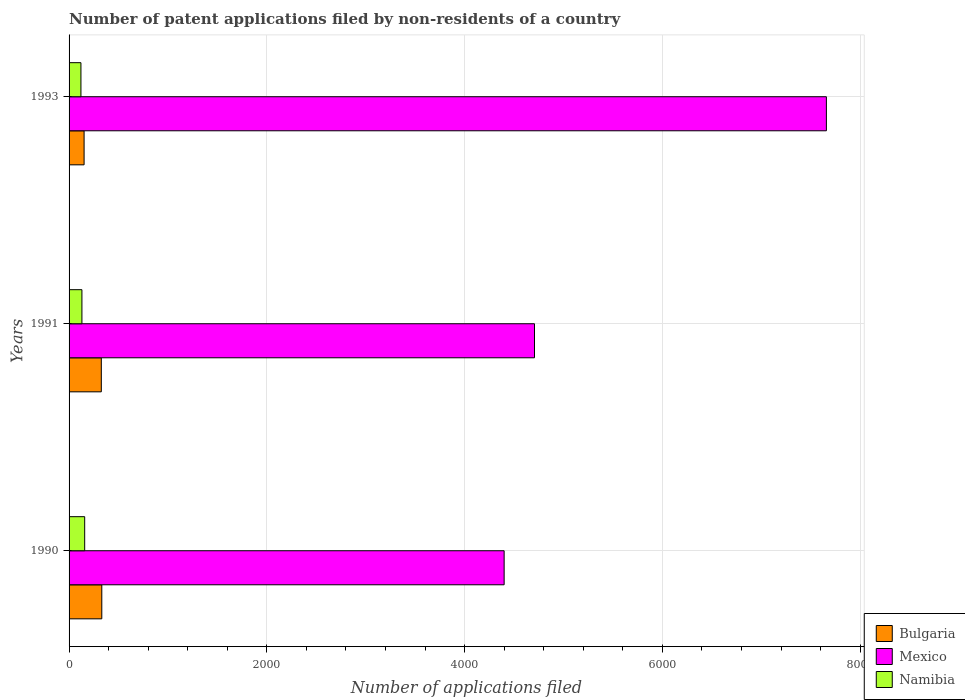How many different coloured bars are there?
Your response must be concise. 3. How many groups of bars are there?
Your answer should be very brief. 3. How many bars are there on the 1st tick from the top?
Make the answer very short. 3. What is the label of the 2nd group of bars from the top?
Your answer should be compact. 1991. What is the number of applications filed in Bulgaria in 1991?
Your answer should be compact. 326. Across all years, what is the maximum number of applications filed in Bulgaria?
Ensure brevity in your answer.  331. Across all years, what is the minimum number of applications filed in Mexico?
Offer a very short reply. 4400. What is the total number of applications filed in Mexico in the graph?
Ensure brevity in your answer.  1.68e+04. What is the difference between the number of applications filed in Bulgaria in 1991 and that in 1993?
Your answer should be compact. 174. What is the difference between the number of applications filed in Namibia in 1993 and the number of applications filed in Mexico in 1991?
Your answer should be compact. -4587. What is the average number of applications filed in Bulgaria per year?
Ensure brevity in your answer.  269.67. In the year 1990, what is the difference between the number of applications filed in Namibia and number of applications filed in Mexico?
Make the answer very short. -4242. In how many years, is the number of applications filed in Bulgaria greater than 4400 ?
Offer a terse response. 0. What is the ratio of the number of applications filed in Namibia in 1990 to that in 1991?
Provide a succinct answer. 1.22. Is the difference between the number of applications filed in Namibia in 1991 and 1993 greater than the difference between the number of applications filed in Mexico in 1991 and 1993?
Offer a terse response. Yes. What is the difference between the highest and the lowest number of applications filed in Bulgaria?
Your response must be concise. 179. Is the sum of the number of applications filed in Namibia in 1990 and 1993 greater than the maximum number of applications filed in Mexico across all years?
Provide a succinct answer. No. What does the 3rd bar from the bottom in 1990 represents?
Offer a very short reply. Namibia. Is it the case that in every year, the sum of the number of applications filed in Mexico and number of applications filed in Bulgaria is greater than the number of applications filed in Namibia?
Your answer should be compact. Yes. Are all the bars in the graph horizontal?
Provide a short and direct response. Yes. How many years are there in the graph?
Offer a terse response. 3. Are the values on the major ticks of X-axis written in scientific E-notation?
Give a very brief answer. No. Does the graph contain grids?
Give a very brief answer. Yes. How many legend labels are there?
Your response must be concise. 3. How are the legend labels stacked?
Your response must be concise. Vertical. What is the title of the graph?
Your response must be concise. Number of patent applications filed by non-residents of a country. What is the label or title of the X-axis?
Provide a short and direct response. Number of applications filed. What is the Number of applications filed in Bulgaria in 1990?
Your answer should be compact. 331. What is the Number of applications filed in Mexico in 1990?
Your answer should be compact. 4400. What is the Number of applications filed of Namibia in 1990?
Make the answer very short. 158. What is the Number of applications filed in Bulgaria in 1991?
Your response must be concise. 326. What is the Number of applications filed in Mexico in 1991?
Your answer should be compact. 4707. What is the Number of applications filed of Namibia in 1991?
Offer a terse response. 130. What is the Number of applications filed of Bulgaria in 1993?
Offer a very short reply. 152. What is the Number of applications filed of Mexico in 1993?
Provide a succinct answer. 7659. What is the Number of applications filed in Namibia in 1993?
Keep it short and to the point. 120. Across all years, what is the maximum Number of applications filed of Bulgaria?
Keep it short and to the point. 331. Across all years, what is the maximum Number of applications filed in Mexico?
Your response must be concise. 7659. Across all years, what is the maximum Number of applications filed in Namibia?
Your response must be concise. 158. Across all years, what is the minimum Number of applications filed in Bulgaria?
Give a very brief answer. 152. Across all years, what is the minimum Number of applications filed in Mexico?
Make the answer very short. 4400. Across all years, what is the minimum Number of applications filed of Namibia?
Your answer should be very brief. 120. What is the total Number of applications filed of Bulgaria in the graph?
Your response must be concise. 809. What is the total Number of applications filed in Mexico in the graph?
Give a very brief answer. 1.68e+04. What is the total Number of applications filed in Namibia in the graph?
Your answer should be compact. 408. What is the difference between the Number of applications filed in Bulgaria in 1990 and that in 1991?
Offer a very short reply. 5. What is the difference between the Number of applications filed in Mexico in 1990 and that in 1991?
Ensure brevity in your answer.  -307. What is the difference between the Number of applications filed of Namibia in 1990 and that in 1991?
Ensure brevity in your answer.  28. What is the difference between the Number of applications filed of Bulgaria in 1990 and that in 1993?
Provide a succinct answer. 179. What is the difference between the Number of applications filed in Mexico in 1990 and that in 1993?
Provide a short and direct response. -3259. What is the difference between the Number of applications filed of Namibia in 1990 and that in 1993?
Offer a very short reply. 38. What is the difference between the Number of applications filed of Bulgaria in 1991 and that in 1993?
Offer a terse response. 174. What is the difference between the Number of applications filed of Mexico in 1991 and that in 1993?
Provide a succinct answer. -2952. What is the difference between the Number of applications filed of Namibia in 1991 and that in 1993?
Offer a terse response. 10. What is the difference between the Number of applications filed in Bulgaria in 1990 and the Number of applications filed in Mexico in 1991?
Your answer should be compact. -4376. What is the difference between the Number of applications filed in Bulgaria in 1990 and the Number of applications filed in Namibia in 1991?
Ensure brevity in your answer.  201. What is the difference between the Number of applications filed of Mexico in 1990 and the Number of applications filed of Namibia in 1991?
Keep it short and to the point. 4270. What is the difference between the Number of applications filed in Bulgaria in 1990 and the Number of applications filed in Mexico in 1993?
Give a very brief answer. -7328. What is the difference between the Number of applications filed of Bulgaria in 1990 and the Number of applications filed of Namibia in 1993?
Offer a terse response. 211. What is the difference between the Number of applications filed of Mexico in 1990 and the Number of applications filed of Namibia in 1993?
Your answer should be compact. 4280. What is the difference between the Number of applications filed in Bulgaria in 1991 and the Number of applications filed in Mexico in 1993?
Your answer should be compact. -7333. What is the difference between the Number of applications filed in Bulgaria in 1991 and the Number of applications filed in Namibia in 1993?
Give a very brief answer. 206. What is the difference between the Number of applications filed of Mexico in 1991 and the Number of applications filed of Namibia in 1993?
Your answer should be very brief. 4587. What is the average Number of applications filed of Bulgaria per year?
Make the answer very short. 269.67. What is the average Number of applications filed of Mexico per year?
Your answer should be compact. 5588.67. What is the average Number of applications filed of Namibia per year?
Keep it short and to the point. 136. In the year 1990, what is the difference between the Number of applications filed of Bulgaria and Number of applications filed of Mexico?
Provide a short and direct response. -4069. In the year 1990, what is the difference between the Number of applications filed of Bulgaria and Number of applications filed of Namibia?
Offer a very short reply. 173. In the year 1990, what is the difference between the Number of applications filed of Mexico and Number of applications filed of Namibia?
Keep it short and to the point. 4242. In the year 1991, what is the difference between the Number of applications filed of Bulgaria and Number of applications filed of Mexico?
Your answer should be very brief. -4381. In the year 1991, what is the difference between the Number of applications filed in Bulgaria and Number of applications filed in Namibia?
Your response must be concise. 196. In the year 1991, what is the difference between the Number of applications filed of Mexico and Number of applications filed of Namibia?
Ensure brevity in your answer.  4577. In the year 1993, what is the difference between the Number of applications filed in Bulgaria and Number of applications filed in Mexico?
Make the answer very short. -7507. In the year 1993, what is the difference between the Number of applications filed in Bulgaria and Number of applications filed in Namibia?
Your answer should be compact. 32. In the year 1993, what is the difference between the Number of applications filed of Mexico and Number of applications filed of Namibia?
Your response must be concise. 7539. What is the ratio of the Number of applications filed of Bulgaria in 1990 to that in 1991?
Keep it short and to the point. 1.02. What is the ratio of the Number of applications filed in Mexico in 1990 to that in 1991?
Provide a short and direct response. 0.93. What is the ratio of the Number of applications filed in Namibia in 1990 to that in 1991?
Provide a short and direct response. 1.22. What is the ratio of the Number of applications filed of Bulgaria in 1990 to that in 1993?
Keep it short and to the point. 2.18. What is the ratio of the Number of applications filed of Mexico in 1990 to that in 1993?
Provide a short and direct response. 0.57. What is the ratio of the Number of applications filed in Namibia in 1990 to that in 1993?
Your answer should be very brief. 1.32. What is the ratio of the Number of applications filed in Bulgaria in 1991 to that in 1993?
Your answer should be compact. 2.14. What is the ratio of the Number of applications filed of Mexico in 1991 to that in 1993?
Your answer should be very brief. 0.61. What is the difference between the highest and the second highest Number of applications filed of Bulgaria?
Ensure brevity in your answer.  5. What is the difference between the highest and the second highest Number of applications filed of Mexico?
Provide a short and direct response. 2952. What is the difference between the highest and the lowest Number of applications filed of Bulgaria?
Your answer should be compact. 179. What is the difference between the highest and the lowest Number of applications filed of Mexico?
Your response must be concise. 3259. What is the difference between the highest and the lowest Number of applications filed of Namibia?
Provide a succinct answer. 38. 